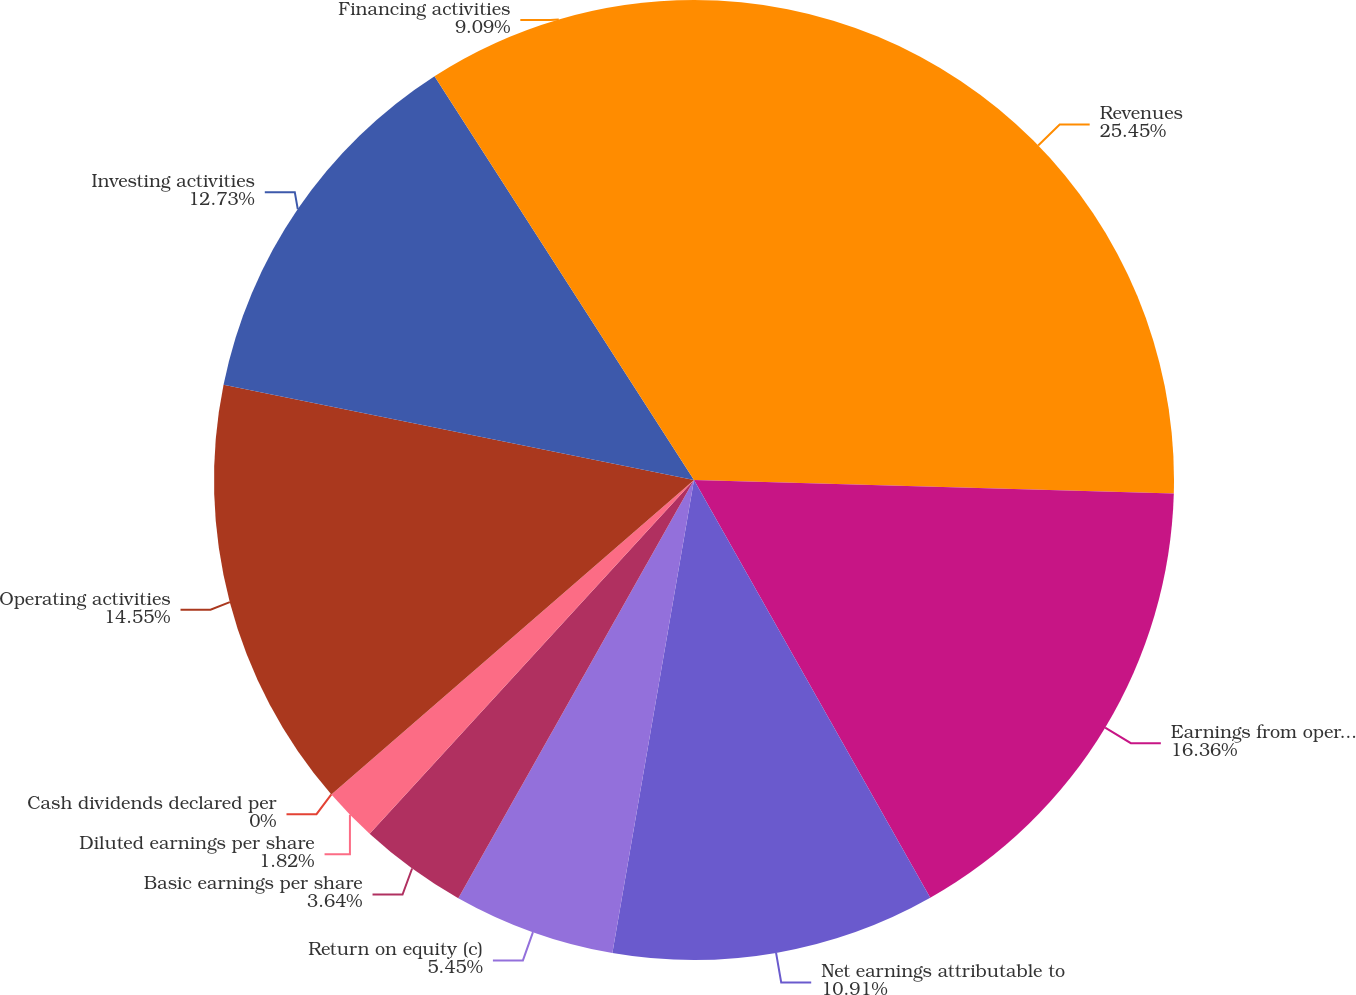Convert chart to OTSL. <chart><loc_0><loc_0><loc_500><loc_500><pie_chart><fcel>Revenues<fcel>Earnings from operations<fcel>Net earnings attributable to<fcel>Return on equity (c)<fcel>Basic earnings per share<fcel>Diluted earnings per share<fcel>Cash dividends declared per<fcel>Operating activities<fcel>Investing activities<fcel>Financing activities<nl><fcel>25.45%<fcel>16.36%<fcel>10.91%<fcel>5.45%<fcel>3.64%<fcel>1.82%<fcel>0.0%<fcel>14.55%<fcel>12.73%<fcel>9.09%<nl></chart> 